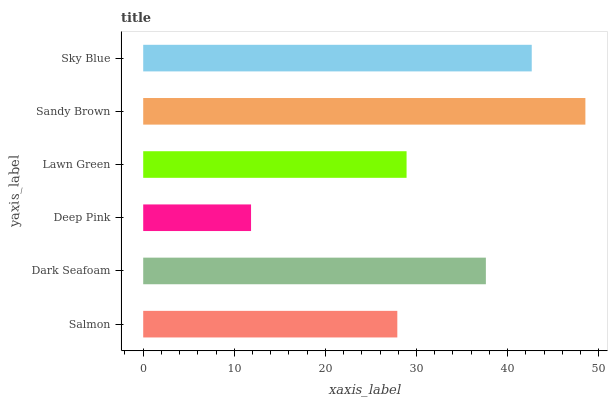Is Deep Pink the minimum?
Answer yes or no. Yes. Is Sandy Brown the maximum?
Answer yes or no. Yes. Is Dark Seafoam the minimum?
Answer yes or no. No. Is Dark Seafoam the maximum?
Answer yes or no. No. Is Dark Seafoam greater than Salmon?
Answer yes or no. Yes. Is Salmon less than Dark Seafoam?
Answer yes or no. Yes. Is Salmon greater than Dark Seafoam?
Answer yes or no. No. Is Dark Seafoam less than Salmon?
Answer yes or no. No. Is Dark Seafoam the high median?
Answer yes or no. Yes. Is Lawn Green the low median?
Answer yes or no. Yes. Is Deep Pink the high median?
Answer yes or no. No. Is Deep Pink the low median?
Answer yes or no. No. 